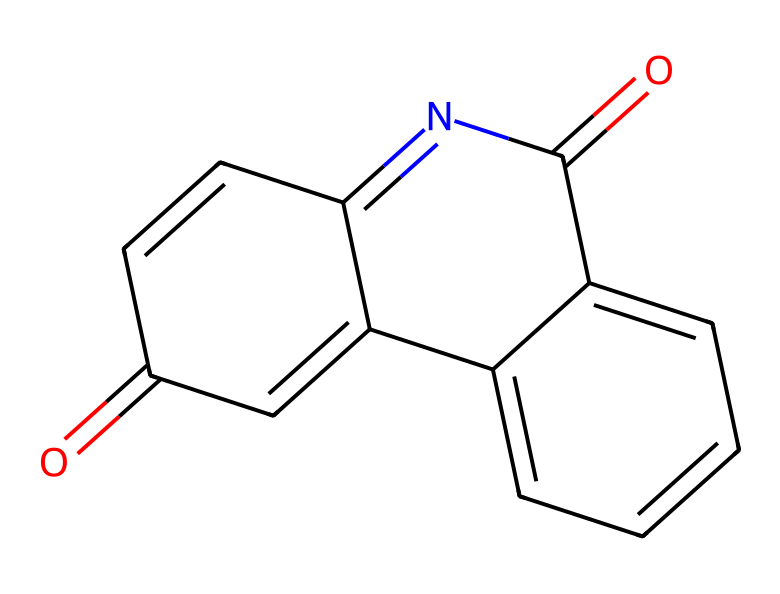What is the molecular formula of this compound? To determine the molecular formula, count the number of each type of atom in the SMILES representation. The atoms present are: Carbon (C): 15, Hydrogen (H): 10, Nitrogen (N): 2, and Oxygen (O): 2. Therefore, the molecular formula is C15H10N2O2.
Answer: C15H10N2O2 How many rings are present in this chemical structure? By analyzing the structure, we see that there are three fused rings in the compound. Each ring can be counted from the structure represented in the SMILES notation.
Answer: 3 What functional groups are evident in this chemical? The functional groups present can be identified from the structure. There are carbonyl (C=O) and imine (C=N) groups. These are key features in the chemical's reactivity and properties.
Answer: carbonyl and imine What is the significance of diazonaphthoquinone in photolithography? Diazonaphthoquinone is a critical photoresist compound used in photolithography processes. It serves as a light-sensitive material that helps in the patterning of photosensitive surfaces.
Answer: photoresist Which element makes this chemical reactive under UV light? The presence of nitrogen in the diazonaphthoquinone structure contributes to its reactivity under UV light, enabling it to undergo a chemical reaction upon exposure.
Answer: nitrogen 